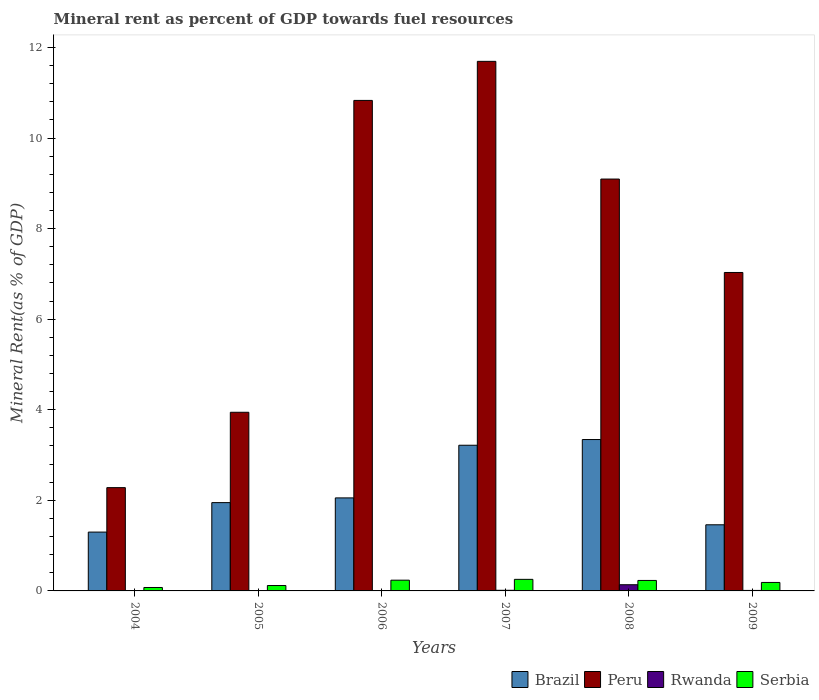Are the number of bars per tick equal to the number of legend labels?
Your answer should be very brief. Yes. How many bars are there on the 1st tick from the left?
Provide a succinct answer. 4. In how many cases, is the number of bars for a given year not equal to the number of legend labels?
Provide a short and direct response. 0. What is the mineral rent in Serbia in 2009?
Provide a short and direct response. 0.19. Across all years, what is the maximum mineral rent in Brazil?
Provide a short and direct response. 3.34. Across all years, what is the minimum mineral rent in Brazil?
Offer a terse response. 1.3. What is the total mineral rent in Peru in the graph?
Offer a very short reply. 44.87. What is the difference between the mineral rent in Serbia in 2005 and that in 2006?
Keep it short and to the point. -0.12. What is the difference between the mineral rent in Peru in 2008 and the mineral rent in Brazil in 2009?
Provide a succinct answer. 7.63. What is the average mineral rent in Rwanda per year?
Your answer should be compact. 0.03. In the year 2009, what is the difference between the mineral rent in Brazil and mineral rent in Peru?
Offer a terse response. -5.57. In how many years, is the mineral rent in Peru greater than 4 %?
Provide a short and direct response. 4. What is the ratio of the mineral rent in Brazil in 2006 to that in 2007?
Make the answer very short. 0.64. Is the mineral rent in Serbia in 2006 less than that in 2009?
Your answer should be compact. No. Is the difference between the mineral rent in Brazil in 2005 and 2007 greater than the difference between the mineral rent in Peru in 2005 and 2007?
Keep it short and to the point. Yes. What is the difference between the highest and the second highest mineral rent in Peru?
Provide a short and direct response. 0.86. What is the difference between the highest and the lowest mineral rent in Peru?
Offer a very short reply. 9.41. Is the sum of the mineral rent in Rwanda in 2005 and 2006 greater than the maximum mineral rent in Peru across all years?
Provide a succinct answer. No. Is it the case that in every year, the sum of the mineral rent in Rwanda and mineral rent in Brazil is greater than the sum of mineral rent in Peru and mineral rent in Serbia?
Your response must be concise. No. What does the 1st bar from the left in 2007 represents?
Make the answer very short. Brazil. What does the 4th bar from the right in 2008 represents?
Provide a short and direct response. Brazil. What is the difference between two consecutive major ticks on the Y-axis?
Keep it short and to the point. 2. Are the values on the major ticks of Y-axis written in scientific E-notation?
Provide a succinct answer. No. What is the title of the graph?
Offer a terse response. Mineral rent as percent of GDP towards fuel resources. Does "France" appear as one of the legend labels in the graph?
Offer a very short reply. No. What is the label or title of the Y-axis?
Ensure brevity in your answer.  Mineral Rent(as % of GDP). What is the Mineral Rent(as % of GDP) of Brazil in 2004?
Provide a short and direct response. 1.3. What is the Mineral Rent(as % of GDP) in Peru in 2004?
Keep it short and to the point. 2.28. What is the Mineral Rent(as % of GDP) in Rwanda in 2004?
Keep it short and to the point. 0. What is the Mineral Rent(as % of GDP) in Serbia in 2004?
Keep it short and to the point. 0.08. What is the Mineral Rent(as % of GDP) of Brazil in 2005?
Keep it short and to the point. 1.95. What is the Mineral Rent(as % of GDP) of Peru in 2005?
Make the answer very short. 3.94. What is the Mineral Rent(as % of GDP) in Rwanda in 2005?
Ensure brevity in your answer.  0. What is the Mineral Rent(as % of GDP) of Serbia in 2005?
Your answer should be compact. 0.12. What is the Mineral Rent(as % of GDP) of Brazil in 2006?
Keep it short and to the point. 2.05. What is the Mineral Rent(as % of GDP) of Peru in 2006?
Your answer should be compact. 10.83. What is the Mineral Rent(as % of GDP) of Rwanda in 2006?
Make the answer very short. 0. What is the Mineral Rent(as % of GDP) of Serbia in 2006?
Your answer should be compact. 0.24. What is the Mineral Rent(as % of GDP) of Brazil in 2007?
Provide a succinct answer. 3.22. What is the Mineral Rent(as % of GDP) in Peru in 2007?
Ensure brevity in your answer.  11.69. What is the Mineral Rent(as % of GDP) of Rwanda in 2007?
Keep it short and to the point. 0.01. What is the Mineral Rent(as % of GDP) in Serbia in 2007?
Make the answer very short. 0.26. What is the Mineral Rent(as % of GDP) in Brazil in 2008?
Provide a succinct answer. 3.34. What is the Mineral Rent(as % of GDP) in Peru in 2008?
Your answer should be very brief. 9.09. What is the Mineral Rent(as % of GDP) of Rwanda in 2008?
Provide a short and direct response. 0.14. What is the Mineral Rent(as % of GDP) of Serbia in 2008?
Provide a succinct answer. 0.23. What is the Mineral Rent(as % of GDP) of Brazil in 2009?
Your answer should be compact. 1.46. What is the Mineral Rent(as % of GDP) in Peru in 2009?
Keep it short and to the point. 7.03. What is the Mineral Rent(as % of GDP) in Rwanda in 2009?
Offer a terse response. 0.01. What is the Mineral Rent(as % of GDP) of Serbia in 2009?
Your answer should be compact. 0.19. Across all years, what is the maximum Mineral Rent(as % of GDP) in Brazil?
Keep it short and to the point. 3.34. Across all years, what is the maximum Mineral Rent(as % of GDP) of Peru?
Your answer should be compact. 11.69. Across all years, what is the maximum Mineral Rent(as % of GDP) of Rwanda?
Your answer should be compact. 0.14. Across all years, what is the maximum Mineral Rent(as % of GDP) in Serbia?
Make the answer very short. 0.26. Across all years, what is the minimum Mineral Rent(as % of GDP) of Brazil?
Your answer should be compact. 1.3. Across all years, what is the minimum Mineral Rent(as % of GDP) of Peru?
Offer a terse response. 2.28. Across all years, what is the minimum Mineral Rent(as % of GDP) in Rwanda?
Your answer should be compact. 0. Across all years, what is the minimum Mineral Rent(as % of GDP) of Serbia?
Make the answer very short. 0.08. What is the total Mineral Rent(as % of GDP) of Brazil in the graph?
Give a very brief answer. 13.32. What is the total Mineral Rent(as % of GDP) of Peru in the graph?
Your answer should be very brief. 44.87. What is the total Mineral Rent(as % of GDP) in Rwanda in the graph?
Ensure brevity in your answer.  0.17. What is the total Mineral Rent(as % of GDP) of Serbia in the graph?
Your answer should be compact. 1.11. What is the difference between the Mineral Rent(as % of GDP) in Brazil in 2004 and that in 2005?
Provide a succinct answer. -0.65. What is the difference between the Mineral Rent(as % of GDP) in Peru in 2004 and that in 2005?
Your answer should be very brief. -1.66. What is the difference between the Mineral Rent(as % of GDP) of Rwanda in 2004 and that in 2005?
Ensure brevity in your answer.  -0. What is the difference between the Mineral Rent(as % of GDP) of Serbia in 2004 and that in 2005?
Your answer should be very brief. -0.04. What is the difference between the Mineral Rent(as % of GDP) of Brazil in 2004 and that in 2006?
Keep it short and to the point. -0.75. What is the difference between the Mineral Rent(as % of GDP) of Peru in 2004 and that in 2006?
Your answer should be very brief. -8.55. What is the difference between the Mineral Rent(as % of GDP) in Rwanda in 2004 and that in 2006?
Make the answer very short. -0. What is the difference between the Mineral Rent(as % of GDP) of Serbia in 2004 and that in 2006?
Your answer should be compact. -0.16. What is the difference between the Mineral Rent(as % of GDP) of Brazil in 2004 and that in 2007?
Offer a very short reply. -1.92. What is the difference between the Mineral Rent(as % of GDP) of Peru in 2004 and that in 2007?
Your response must be concise. -9.41. What is the difference between the Mineral Rent(as % of GDP) of Rwanda in 2004 and that in 2007?
Provide a succinct answer. -0.01. What is the difference between the Mineral Rent(as % of GDP) in Serbia in 2004 and that in 2007?
Provide a short and direct response. -0.18. What is the difference between the Mineral Rent(as % of GDP) in Brazil in 2004 and that in 2008?
Your response must be concise. -2.04. What is the difference between the Mineral Rent(as % of GDP) of Peru in 2004 and that in 2008?
Keep it short and to the point. -6.81. What is the difference between the Mineral Rent(as % of GDP) of Rwanda in 2004 and that in 2008?
Keep it short and to the point. -0.14. What is the difference between the Mineral Rent(as % of GDP) of Serbia in 2004 and that in 2008?
Ensure brevity in your answer.  -0.16. What is the difference between the Mineral Rent(as % of GDP) of Brazil in 2004 and that in 2009?
Provide a succinct answer. -0.16. What is the difference between the Mineral Rent(as % of GDP) in Peru in 2004 and that in 2009?
Your answer should be compact. -4.75. What is the difference between the Mineral Rent(as % of GDP) in Rwanda in 2004 and that in 2009?
Give a very brief answer. -0.01. What is the difference between the Mineral Rent(as % of GDP) of Serbia in 2004 and that in 2009?
Provide a short and direct response. -0.11. What is the difference between the Mineral Rent(as % of GDP) in Brazil in 2005 and that in 2006?
Your response must be concise. -0.1. What is the difference between the Mineral Rent(as % of GDP) of Peru in 2005 and that in 2006?
Your answer should be very brief. -6.89. What is the difference between the Mineral Rent(as % of GDP) in Rwanda in 2005 and that in 2006?
Ensure brevity in your answer.  -0. What is the difference between the Mineral Rent(as % of GDP) in Serbia in 2005 and that in 2006?
Offer a very short reply. -0.12. What is the difference between the Mineral Rent(as % of GDP) in Brazil in 2005 and that in 2007?
Keep it short and to the point. -1.27. What is the difference between the Mineral Rent(as % of GDP) of Peru in 2005 and that in 2007?
Your response must be concise. -7.75. What is the difference between the Mineral Rent(as % of GDP) in Rwanda in 2005 and that in 2007?
Your response must be concise. -0.01. What is the difference between the Mineral Rent(as % of GDP) in Serbia in 2005 and that in 2007?
Make the answer very short. -0.14. What is the difference between the Mineral Rent(as % of GDP) in Brazil in 2005 and that in 2008?
Keep it short and to the point. -1.39. What is the difference between the Mineral Rent(as % of GDP) in Peru in 2005 and that in 2008?
Ensure brevity in your answer.  -5.15. What is the difference between the Mineral Rent(as % of GDP) of Rwanda in 2005 and that in 2008?
Your response must be concise. -0.14. What is the difference between the Mineral Rent(as % of GDP) of Serbia in 2005 and that in 2008?
Your answer should be very brief. -0.11. What is the difference between the Mineral Rent(as % of GDP) of Brazil in 2005 and that in 2009?
Your response must be concise. 0.49. What is the difference between the Mineral Rent(as % of GDP) in Peru in 2005 and that in 2009?
Provide a short and direct response. -3.09. What is the difference between the Mineral Rent(as % of GDP) in Rwanda in 2005 and that in 2009?
Ensure brevity in your answer.  -0.01. What is the difference between the Mineral Rent(as % of GDP) of Serbia in 2005 and that in 2009?
Offer a very short reply. -0.07. What is the difference between the Mineral Rent(as % of GDP) in Brazil in 2006 and that in 2007?
Offer a very short reply. -1.16. What is the difference between the Mineral Rent(as % of GDP) of Peru in 2006 and that in 2007?
Offer a very short reply. -0.86. What is the difference between the Mineral Rent(as % of GDP) in Rwanda in 2006 and that in 2007?
Keep it short and to the point. -0.01. What is the difference between the Mineral Rent(as % of GDP) of Serbia in 2006 and that in 2007?
Your answer should be compact. -0.02. What is the difference between the Mineral Rent(as % of GDP) in Brazil in 2006 and that in 2008?
Provide a short and direct response. -1.29. What is the difference between the Mineral Rent(as % of GDP) in Peru in 2006 and that in 2008?
Your answer should be compact. 1.74. What is the difference between the Mineral Rent(as % of GDP) in Rwanda in 2006 and that in 2008?
Make the answer very short. -0.13. What is the difference between the Mineral Rent(as % of GDP) of Serbia in 2006 and that in 2008?
Make the answer very short. 0.01. What is the difference between the Mineral Rent(as % of GDP) in Brazil in 2006 and that in 2009?
Your response must be concise. 0.59. What is the difference between the Mineral Rent(as % of GDP) of Peru in 2006 and that in 2009?
Your answer should be very brief. 3.8. What is the difference between the Mineral Rent(as % of GDP) of Rwanda in 2006 and that in 2009?
Provide a succinct answer. -0.01. What is the difference between the Mineral Rent(as % of GDP) of Serbia in 2006 and that in 2009?
Offer a terse response. 0.05. What is the difference between the Mineral Rent(as % of GDP) of Brazil in 2007 and that in 2008?
Offer a very short reply. -0.13. What is the difference between the Mineral Rent(as % of GDP) of Peru in 2007 and that in 2008?
Offer a terse response. 2.6. What is the difference between the Mineral Rent(as % of GDP) in Rwanda in 2007 and that in 2008?
Offer a terse response. -0.12. What is the difference between the Mineral Rent(as % of GDP) of Serbia in 2007 and that in 2008?
Provide a short and direct response. 0.02. What is the difference between the Mineral Rent(as % of GDP) of Brazil in 2007 and that in 2009?
Give a very brief answer. 1.76. What is the difference between the Mineral Rent(as % of GDP) in Peru in 2007 and that in 2009?
Ensure brevity in your answer.  4.66. What is the difference between the Mineral Rent(as % of GDP) of Rwanda in 2007 and that in 2009?
Your answer should be compact. 0. What is the difference between the Mineral Rent(as % of GDP) of Serbia in 2007 and that in 2009?
Ensure brevity in your answer.  0.07. What is the difference between the Mineral Rent(as % of GDP) in Brazil in 2008 and that in 2009?
Your answer should be compact. 1.88. What is the difference between the Mineral Rent(as % of GDP) in Peru in 2008 and that in 2009?
Ensure brevity in your answer.  2.06. What is the difference between the Mineral Rent(as % of GDP) in Rwanda in 2008 and that in 2009?
Your answer should be very brief. 0.13. What is the difference between the Mineral Rent(as % of GDP) in Serbia in 2008 and that in 2009?
Make the answer very short. 0.04. What is the difference between the Mineral Rent(as % of GDP) of Brazil in 2004 and the Mineral Rent(as % of GDP) of Peru in 2005?
Provide a short and direct response. -2.65. What is the difference between the Mineral Rent(as % of GDP) of Brazil in 2004 and the Mineral Rent(as % of GDP) of Rwanda in 2005?
Your answer should be compact. 1.3. What is the difference between the Mineral Rent(as % of GDP) in Brazil in 2004 and the Mineral Rent(as % of GDP) in Serbia in 2005?
Your response must be concise. 1.18. What is the difference between the Mineral Rent(as % of GDP) of Peru in 2004 and the Mineral Rent(as % of GDP) of Rwanda in 2005?
Your response must be concise. 2.28. What is the difference between the Mineral Rent(as % of GDP) of Peru in 2004 and the Mineral Rent(as % of GDP) of Serbia in 2005?
Ensure brevity in your answer.  2.16. What is the difference between the Mineral Rent(as % of GDP) of Rwanda in 2004 and the Mineral Rent(as % of GDP) of Serbia in 2005?
Offer a terse response. -0.12. What is the difference between the Mineral Rent(as % of GDP) of Brazil in 2004 and the Mineral Rent(as % of GDP) of Peru in 2006?
Ensure brevity in your answer.  -9.53. What is the difference between the Mineral Rent(as % of GDP) in Brazil in 2004 and the Mineral Rent(as % of GDP) in Rwanda in 2006?
Provide a succinct answer. 1.29. What is the difference between the Mineral Rent(as % of GDP) of Brazil in 2004 and the Mineral Rent(as % of GDP) of Serbia in 2006?
Your answer should be compact. 1.06. What is the difference between the Mineral Rent(as % of GDP) in Peru in 2004 and the Mineral Rent(as % of GDP) in Rwanda in 2006?
Provide a short and direct response. 2.28. What is the difference between the Mineral Rent(as % of GDP) in Peru in 2004 and the Mineral Rent(as % of GDP) in Serbia in 2006?
Your answer should be compact. 2.04. What is the difference between the Mineral Rent(as % of GDP) of Rwanda in 2004 and the Mineral Rent(as % of GDP) of Serbia in 2006?
Offer a very short reply. -0.24. What is the difference between the Mineral Rent(as % of GDP) in Brazil in 2004 and the Mineral Rent(as % of GDP) in Peru in 2007?
Provide a succinct answer. -10.39. What is the difference between the Mineral Rent(as % of GDP) of Brazil in 2004 and the Mineral Rent(as % of GDP) of Rwanda in 2007?
Offer a very short reply. 1.29. What is the difference between the Mineral Rent(as % of GDP) of Brazil in 2004 and the Mineral Rent(as % of GDP) of Serbia in 2007?
Offer a terse response. 1.04. What is the difference between the Mineral Rent(as % of GDP) of Peru in 2004 and the Mineral Rent(as % of GDP) of Rwanda in 2007?
Your answer should be compact. 2.27. What is the difference between the Mineral Rent(as % of GDP) in Peru in 2004 and the Mineral Rent(as % of GDP) in Serbia in 2007?
Make the answer very short. 2.02. What is the difference between the Mineral Rent(as % of GDP) of Rwanda in 2004 and the Mineral Rent(as % of GDP) of Serbia in 2007?
Keep it short and to the point. -0.25. What is the difference between the Mineral Rent(as % of GDP) in Brazil in 2004 and the Mineral Rent(as % of GDP) in Peru in 2008?
Your answer should be compact. -7.79. What is the difference between the Mineral Rent(as % of GDP) of Brazil in 2004 and the Mineral Rent(as % of GDP) of Rwanda in 2008?
Make the answer very short. 1.16. What is the difference between the Mineral Rent(as % of GDP) of Brazil in 2004 and the Mineral Rent(as % of GDP) of Serbia in 2008?
Provide a succinct answer. 1.07. What is the difference between the Mineral Rent(as % of GDP) of Peru in 2004 and the Mineral Rent(as % of GDP) of Rwanda in 2008?
Your answer should be very brief. 2.14. What is the difference between the Mineral Rent(as % of GDP) of Peru in 2004 and the Mineral Rent(as % of GDP) of Serbia in 2008?
Offer a very short reply. 2.05. What is the difference between the Mineral Rent(as % of GDP) of Rwanda in 2004 and the Mineral Rent(as % of GDP) of Serbia in 2008?
Give a very brief answer. -0.23. What is the difference between the Mineral Rent(as % of GDP) of Brazil in 2004 and the Mineral Rent(as % of GDP) of Peru in 2009?
Offer a very short reply. -5.73. What is the difference between the Mineral Rent(as % of GDP) of Brazil in 2004 and the Mineral Rent(as % of GDP) of Rwanda in 2009?
Make the answer very short. 1.29. What is the difference between the Mineral Rent(as % of GDP) of Brazil in 2004 and the Mineral Rent(as % of GDP) of Serbia in 2009?
Provide a short and direct response. 1.11. What is the difference between the Mineral Rent(as % of GDP) in Peru in 2004 and the Mineral Rent(as % of GDP) in Rwanda in 2009?
Provide a short and direct response. 2.27. What is the difference between the Mineral Rent(as % of GDP) of Peru in 2004 and the Mineral Rent(as % of GDP) of Serbia in 2009?
Provide a short and direct response. 2.09. What is the difference between the Mineral Rent(as % of GDP) in Rwanda in 2004 and the Mineral Rent(as % of GDP) in Serbia in 2009?
Offer a very short reply. -0.19. What is the difference between the Mineral Rent(as % of GDP) of Brazil in 2005 and the Mineral Rent(as % of GDP) of Peru in 2006?
Keep it short and to the point. -8.88. What is the difference between the Mineral Rent(as % of GDP) in Brazil in 2005 and the Mineral Rent(as % of GDP) in Rwanda in 2006?
Offer a very short reply. 1.95. What is the difference between the Mineral Rent(as % of GDP) of Brazil in 2005 and the Mineral Rent(as % of GDP) of Serbia in 2006?
Your answer should be very brief. 1.71. What is the difference between the Mineral Rent(as % of GDP) of Peru in 2005 and the Mineral Rent(as % of GDP) of Rwanda in 2006?
Your answer should be very brief. 3.94. What is the difference between the Mineral Rent(as % of GDP) of Peru in 2005 and the Mineral Rent(as % of GDP) of Serbia in 2006?
Provide a short and direct response. 3.71. What is the difference between the Mineral Rent(as % of GDP) in Rwanda in 2005 and the Mineral Rent(as % of GDP) in Serbia in 2006?
Provide a succinct answer. -0.24. What is the difference between the Mineral Rent(as % of GDP) of Brazil in 2005 and the Mineral Rent(as % of GDP) of Peru in 2007?
Your response must be concise. -9.74. What is the difference between the Mineral Rent(as % of GDP) of Brazil in 2005 and the Mineral Rent(as % of GDP) of Rwanda in 2007?
Ensure brevity in your answer.  1.94. What is the difference between the Mineral Rent(as % of GDP) of Brazil in 2005 and the Mineral Rent(as % of GDP) of Serbia in 2007?
Ensure brevity in your answer.  1.69. What is the difference between the Mineral Rent(as % of GDP) of Peru in 2005 and the Mineral Rent(as % of GDP) of Rwanda in 2007?
Your answer should be very brief. 3.93. What is the difference between the Mineral Rent(as % of GDP) in Peru in 2005 and the Mineral Rent(as % of GDP) in Serbia in 2007?
Keep it short and to the point. 3.69. What is the difference between the Mineral Rent(as % of GDP) in Rwanda in 2005 and the Mineral Rent(as % of GDP) in Serbia in 2007?
Offer a terse response. -0.25. What is the difference between the Mineral Rent(as % of GDP) of Brazil in 2005 and the Mineral Rent(as % of GDP) of Peru in 2008?
Your response must be concise. -7.14. What is the difference between the Mineral Rent(as % of GDP) in Brazil in 2005 and the Mineral Rent(as % of GDP) in Rwanda in 2008?
Keep it short and to the point. 1.81. What is the difference between the Mineral Rent(as % of GDP) in Brazil in 2005 and the Mineral Rent(as % of GDP) in Serbia in 2008?
Provide a succinct answer. 1.72. What is the difference between the Mineral Rent(as % of GDP) in Peru in 2005 and the Mineral Rent(as % of GDP) in Rwanda in 2008?
Keep it short and to the point. 3.81. What is the difference between the Mineral Rent(as % of GDP) in Peru in 2005 and the Mineral Rent(as % of GDP) in Serbia in 2008?
Provide a short and direct response. 3.71. What is the difference between the Mineral Rent(as % of GDP) in Rwanda in 2005 and the Mineral Rent(as % of GDP) in Serbia in 2008?
Give a very brief answer. -0.23. What is the difference between the Mineral Rent(as % of GDP) in Brazil in 2005 and the Mineral Rent(as % of GDP) in Peru in 2009?
Provide a succinct answer. -5.08. What is the difference between the Mineral Rent(as % of GDP) of Brazil in 2005 and the Mineral Rent(as % of GDP) of Rwanda in 2009?
Offer a very short reply. 1.94. What is the difference between the Mineral Rent(as % of GDP) in Brazil in 2005 and the Mineral Rent(as % of GDP) in Serbia in 2009?
Provide a succinct answer. 1.76. What is the difference between the Mineral Rent(as % of GDP) in Peru in 2005 and the Mineral Rent(as % of GDP) in Rwanda in 2009?
Offer a terse response. 3.93. What is the difference between the Mineral Rent(as % of GDP) in Peru in 2005 and the Mineral Rent(as % of GDP) in Serbia in 2009?
Offer a terse response. 3.76. What is the difference between the Mineral Rent(as % of GDP) in Rwanda in 2005 and the Mineral Rent(as % of GDP) in Serbia in 2009?
Make the answer very short. -0.19. What is the difference between the Mineral Rent(as % of GDP) in Brazil in 2006 and the Mineral Rent(as % of GDP) in Peru in 2007?
Give a very brief answer. -9.64. What is the difference between the Mineral Rent(as % of GDP) of Brazil in 2006 and the Mineral Rent(as % of GDP) of Rwanda in 2007?
Keep it short and to the point. 2.04. What is the difference between the Mineral Rent(as % of GDP) in Brazil in 2006 and the Mineral Rent(as % of GDP) in Serbia in 2007?
Ensure brevity in your answer.  1.8. What is the difference between the Mineral Rent(as % of GDP) of Peru in 2006 and the Mineral Rent(as % of GDP) of Rwanda in 2007?
Offer a terse response. 10.82. What is the difference between the Mineral Rent(as % of GDP) of Peru in 2006 and the Mineral Rent(as % of GDP) of Serbia in 2007?
Offer a terse response. 10.57. What is the difference between the Mineral Rent(as % of GDP) in Rwanda in 2006 and the Mineral Rent(as % of GDP) in Serbia in 2007?
Offer a terse response. -0.25. What is the difference between the Mineral Rent(as % of GDP) of Brazil in 2006 and the Mineral Rent(as % of GDP) of Peru in 2008?
Make the answer very short. -7.04. What is the difference between the Mineral Rent(as % of GDP) of Brazil in 2006 and the Mineral Rent(as % of GDP) of Rwanda in 2008?
Your answer should be compact. 1.92. What is the difference between the Mineral Rent(as % of GDP) of Brazil in 2006 and the Mineral Rent(as % of GDP) of Serbia in 2008?
Provide a short and direct response. 1.82. What is the difference between the Mineral Rent(as % of GDP) of Peru in 2006 and the Mineral Rent(as % of GDP) of Rwanda in 2008?
Ensure brevity in your answer.  10.69. What is the difference between the Mineral Rent(as % of GDP) in Peru in 2006 and the Mineral Rent(as % of GDP) in Serbia in 2008?
Give a very brief answer. 10.6. What is the difference between the Mineral Rent(as % of GDP) of Rwanda in 2006 and the Mineral Rent(as % of GDP) of Serbia in 2008?
Your answer should be very brief. -0.23. What is the difference between the Mineral Rent(as % of GDP) of Brazil in 2006 and the Mineral Rent(as % of GDP) of Peru in 2009?
Your answer should be very brief. -4.98. What is the difference between the Mineral Rent(as % of GDP) of Brazil in 2006 and the Mineral Rent(as % of GDP) of Rwanda in 2009?
Ensure brevity in your answer.  2.04. What is the difference between the Mineral Rent(as % of GDP) of Brazil in 2006 and the Mineral Rent(as % of GDP) of Serbia in 2009?
Provide a succinct answer. 1.87. What is the difference between the Mineral Rent(as % of GDP) in Peru in 2006 and the Mineral Rent(as % of GDP) in Rwanda in 2009?
Provide a short and direct response. 10.82. What is the difference between the Mineral Rent(as % of GDP) of Peru in 2006 and the Mineral Rent(as % of GDP) of Serbia in 2009?
Provide a succinct answer. 10.64. What is the difference between the Mineral Rent(as % of GDP) in Rwanda in 2006 and the Mineral Rent(as % of GDP) in Serbia in 2009?
Ensure brevity in your answer.  -0.18. What is the difference between the Mineral Rent(as % of GDP) in Brazil in 2007 and the Mineral Rent(as % of GDP) in Peru in 2008?
Give a very brief answer. -5.88. What is the difference between the Mineral Rent(as % of GDP) of Brazil in 2007 and the Mineral Rent(as % of GDP) of Rwanda in 2008?
Offer a very short reply. 3.08. What is the difference between the Mineral Rent(as % of GDP) of Brazil in 2007 and the Mineral Rent(as % of GDP) of Serbia in 2008?
Offer a very short reply. 2.98. What is the difference between the Mineral Rent(as % of GDP) in Peru in 2007 and the Mineral Rent(as % of GDP) in Rwanda in 2008?
Your answer should be very brief. 11.56. What is the difference between the Mineral Rent(as % of GDP) of Peru in 2007 and the Mineral Rent(as % of GDP) of Serbia in 2008?
Provide a short and direct response. 11.46. What is the difference between the Mineral Rent(as % of GDP) in Rwanda in 2007 and the Mineral Rent(as % of GDP) in Serbia in 2008?
Offer a terse response. -0.22. What is the difference between the Mineral Rent(as % of GDP) of Brazil in 2007 and the Mineral Rent(as % of GDP) of Peru in 2009?
Make the answer very short. -3.81. What is the difference between the Mineral Rent(as % of GDP) of Brazil in 2007 and the Mineral Rent(as % of GDP) of Rwanda in 2009?
Your answer should be very brief. 3.21. What is the difference between the Mineral Rent(as % of GDP) in Brazil in 2007 and the Mineral Rent(as % of GDP) in Serbia in 2009?
Your answer should be very brief. 3.03. What is the difference between the Mineral Rent(as % of GDP) of Peru in 2007 and the Mineral Rent(as % of GDP) of Rwanda in 2009?
Ensure brevity in your answer.  11.68. What is the difference between the Mineral Rent(as % of GDP) of Peru in 2007 and the Mineral Rent(as % of GDP) of Serbia in 2009?
Offer a terse response. 11.51. What is the difference between the Mineral Rent(as % of GDP) in Rwanda in 2007 and the Mineral Rent(as % of GDP) in Serbia in 2009?
Provide a short and direct response. -0.17. What is the difference between the Mineral Rent(as % of GDP) of Brazil in 2008 and the Mineral Rent(as % of GDP) of Peru in 2009?
Ensure brevity in your answer.  -3.69. What is the difference between the Mineral Rent(as % of GDP) of Brazil in 2008 and the Mineral Rent(as % of GDP) of Rwanda in 2009?
Offer a terse response. 3.33. What is the difference between the Mineral Rent(as % of GDP) in Brazil in 2008 and the Mineral Rent(as % of GDP) in Serbia in 2009?
Your answer should be very brief. 3.16. What is the difference between the Mineral Rent(as % of GDP) of Peru in 2008 and the Mineral Rent(as % of GDP) of Rwanda in 2009?
Your answer should be very brief. 9.08. What is the difference between the Mineral Rent(as % of GDP) in Peru in 2008 and the Mineral Rent(as % of GDP) in Serbia in 2009?
Your response must be concise. 8.91. What is the difference between the Mineral Rent(as % of GDP) of Rwanda in 2008 and the Mineral Rent(as % of GDP) of Serbia in 2009?
Your answer should be compact. -0.05. What is the average Mineral Rent(as % of GDP) of Brazil per year?
Offer a very short reply. 2.22. What is the average Mineral Rent(as % of GDP) of Peru per year?
Your answer should be compact. 7.48. What is the average Mineral Rent(as % of GDP) in Rwanda per year?
Keep it short and to the point. 0.03. What is the average Mineral Rent(as % of GDP) in Serbia per year?
Provide a short and direct response. 0.18. In the year 2004, what is the difference between the Mineral Rent(as % of GDP) of Brazil and Mineral Rent(as % of GDP) of Peru?
Offer a terse response. -0.98. In the year 2004, what is the difference between the Mineral Rent(as % of GDP) of Brazil and Mineral Rent(as % of GDP) of Rwanda?
Offer a terse response. 1.3. In the year 2004, what is the difference between the Mineral Rent(as % of GDP) in Brazil and Mineral Rent(as % of GDP) in Serbia?
Your answer should be compact. 1.22. In the year 2004, what is the difference between the Mineral Rent(as % of GDP) in Peru and Mineral Rent(as % of GDP) in Rwanda?
Give a very brief answer. 2.28. In the year 2004, what is the difference between the Mineral Rent(as % of GDP) in Peru and Mineral Rent(as % of GDP) in Serbia?
Your answer should be very brief. 2.2. In the year 2004, what is the difference between the Mineral Rent(as % of GDP) in Rwanda and Mineral Rent(as % of GDP) in Serbia?
Offer a very short reply. -0.07. In the year 2005, what is the difference between the Mineral Rent(as % of GDP) in Brazil and Mineral Rent(as % of GDP) in Peru?
Provide a short and direct response. -1.99. In the year 2005, what is the difference between the Mineral Rent(as % of GDP) in Brazil and Mineral Rent(as % of GDP) in Rwanda?
Ensure brevity in your answer.  1.95. In the year 2005, what is the difference between the Mineral Rent(as % of GDP) in Brazil and Mineral Rent(as % of GDP) in Serbia?
Give a very brief answer. 1.83. In the year 2005, what is the difference between the Mineral Rent(as % of GDP) in Peru and Mineral Rent(as % of GDP) in Rwanda?
Provide a short and direct response. 3.94. In the year 2005, what is the difference between the Mineral Rent(as % of GDP) in Peru and Mineral Rent(as % of GDP) in Serbia?
Offer a terse response. 3.83. In the year 2005, what is the difference between the Mineral Rent(as % of GDP) of Rwanda and Mineral Rent(as % of GDP) of Serbia?
Give a very brief answer. -0.12. In the year 2006, what is the difference between the Mineral Rent(as % of GDP) of Brazil and Mineral Rent(as % of GDP) of Peru?
Give a very brief answer. -8.78. In the year 2006, what is the difference between the Mineral Rent(as % of GDP) in Brazil and Mineral Rent(as % of GDP) in Rwanda?
Offer a very short reply. 2.05. In the year 2006, what is the difference between the Mineral Rent(as % of GDP) of Brazil and Mineral Rent(as % of GDP) of Serbia?
Make the answer very short. 1.82. In the year 2006, what is the difference between the Mineral Rent(as % of GDP) of Peru and Mineral Rent(as % of GDP) of Rwanda?
Your response must be concise. 10.83. In the year 2006, what is the difference between the Mineral Rent(as % of GDP) in Peru and Mineral Rent(as % of GDP) in Serbia?
Provide a succinct answer. 10.59. In the year 2006, what is the difference between the Mineral Rent(as % of GDP) in Rwanda and Mineral Rent(as % of GDP) in Serbia?
Your answer should be compact. -0.23. In the year 2007, what is the difference between the Mineral Rent(as % of GDP) in Brazil and Mineral Rent(as % of GDP) in Peru?
Your answer should be compact. -8.48. In the year 2007, what is the difference between the Mineral Rent(as % of GDP) in Brazil and Mineral Rent(as % of GDP) in Rwanda?
Offer a very short reply. 3.2. In the year 2007, what is the difference between the Mineral Rent(as % of GDP) in Brazil and Mineral Rent(as % of GDP) in Serbia?
Offer a terse response. 2.96. In the year 2007, what is the difference between the Mineral Rent(as % of GDP) of Peru and Mineral Rent(as % of GDP) of Rwanda?
Provide a succinct answer. 11.68. In the year 2007, what is the difference between the Mineral Rent(as % of GDP) in Peru and Mineral Rent(as % of GDP) in Serbia?
Make the answer very short. 11.44. In the year 2007, what is the difference between the Mineral Rent(as % of GDP) of Rwanda and Mineral Rent(as % of GDP) of Serbia?
Provide a succinct answer. -0.24. In the year 2008, what is the difference between the Mineral Rent(as % of GDP) in Brazil and Mineral Rent(as % of GDP) in Peru?
Make the answer very short. -5.75. In the year 2008, what is the difference between the Mineral Rent(as % of GDP) of Brazil and Mineral Rent(as % of GDP) of Rwanda?
Provide a succinct answer. 3.21. In the year 2008, what is the difference between the Mineral Rent(as % of GDP) in Brazil and Mineral Rent(as % of GDP) in Serbia?
Provide a succinct answer. 3.11. In the year 2008, what is the difference between the Mineral Rent(as % of GDP) in Peru and Mineral Rent(as % of GDP) in Rwanda?
Your answer should be compact. 8.96. In the year 2008, what is the difference between the Mineral Rent(as % of GDP) in Peru and Mineral Rent(as % of GDP) in Serbia?
Offer a very short reply. 8.86. In the year 2008, what is the difference between the Mineral Rent(as % of GDP) of Rwanda and Mineral Rent(as % of GDP) of Serbia?
Provide a succinct answer. -0.09. In the year 2009, what is the difference between the Mineral Rent(as % of GDP) of Brazil and Mineral Rent(as % of GDP) of Peru?
Offer a very short reply. -5.57. In the year 2009, what is the difference between the Mineral Rent(as % of GDP) in Brazil and Mineral Rent(as % of GDP) in Rwanda?
Your answer should be compact. 1.45. In the year 2009, what is the difference between the Mineral Rent(as % of GDP) in Brazil and Mineral Rent(as % of GDP) in Serbia?
Make the answer very short. 1.27. In the year 2009, what is the difference between the Mineral Rent(as % of GDP) of Peru and Mineral Rent(as % of GDP) of Rwanda?
Keep it short and to the point. 7.02. In the year 2009, what is the difference between the Mineral Rent(as % of GDP) in Peru and Mineral Rent(as % of GDP) in Serbia?
Offer a very short reply. 6.84. In the year 2009, what is the difference between the Mineral Rent(as % of GDP) in Rwanda and Mineral Rent(as % of GDP) in Serbia?
Give a very brief answer. -0.18. What is the ratio of the Mineral Rent(as % of GDP) of Brazil in 2004 to that in 2005?
Your answer should be compact. 0.67. What is the ratio of the Mineral Rent(as % of GDP) of Peru in 2004 to that in 2005?
Provide a succinct answer. 0.58. What is the ratio of the Mineral Rent(as % of GDP) in Rwanda in 2004 to that in 2005?
Keep it short and to the point. 0.48. What is the ratio of the Mineral Rent(as % of GDP) in Serbia in 2004 to that in 2005?
Your response must be concise. 0.64. What is the ratio of the Mineral Rent(as % of GDP) of Brazil in 2004 to that in 2006?
Provide a short and direct response. 0.63. What is the ratio of the Mineral Rent(as % of GDP) of Peru in 2004 to that in 2006?
Keep it short and to the point. 0.21. What is the ratio of the Mineral Rent(as % of GDP) of Rwanda in 2004 to that in 2006?
Give a very brief answer. 0.16. What is the ratio of the Mineral Rent(as % of GDP) of Serbia in 2004 to that in 2006?
Offer a terse response. 0.32. What is the ratio of the Mineral Rent(as % of GDP) of Brazil in 2004 to that in 2007?
Ensure brevity in your answer.  0.4. What is the ratio of the Mineral Rent(as % of GDP) in Peru in 2004 to that in 2007?
Provide a succinct answer. 0.2. What is the ratio of the Mineral Rent(as % of GDP) of Rwanda in 2004 to that in 2007?
Provide a succinct answer. 0.05. What is the ratio of the Mineral Rent(as % of GDP) of Serbia in 2004 to that in 2007?
Ensure brevity in your answer.  0.3. What is the ratio of the Mineral Rent(as % of GDP) in Brazil in 2004 to that in 2008?
Provide a succinct answer. 0.39. What is the ratio of the Mineral Rent(as % of GDP) in Peru in 2004 to that in 2008?
Give a very brief answer. 0.25. What is the ratio of the Mineral Rent(as % of GDP) in Rwanda in 2004 to that in 2008?
Keep it short and to the point. 0. What is the ratio of the Mineral Rent(as % of GDP) in Serbia in 2004 to that in 2008?
Your answer should be very brief. 0.33. What is the ratio of the Mineral Rent(as % of GDP) of Brazil in 2004 to that in 2009?
Offer a terse response. 0.89. What is the ratio of the Mineral Rent(as % of GDP) of Peru in 2004 to that in 2009?
Your response must be concise. 0.32. What is the ratio of the Mineral Rent(as % of GDP) of Rwanda in 2004 to that in 2009?
Your answer should be compact. 0.06. What is the ratio of the Mineral Rent(as % of GDP) of Serbia in 2004 to that in 2009?
Ensure brevity in your answer.  0.4. What is the ratio of the Mineral Rent(as % of GDP) in Brazil in 2005 to that in 2006?
Offer a very short reply. 0.95. What is the ratio of the Mineral Rent(as % of GDP) of Peru in 2005 to that in 2006?
Ensure brevity in your answer.  0.36. What is the ratio of the Mineral Rent(as % of GDP) of Rwanda in 2005 to that in 2006?
Your response must be concise. 0.34. What is the ratio of the Mineral Rent(as % of GDP) in Serbia in 2005 to that in 2006?
Your answer should be compact. 0.5. What is the ratio of the Mineral Rent(as % of GDP) of Brazil in 2005 to that in 2007?
Provide a succinct answer. 0.61. What is the ratio of the Mineral Rent(as % of GDP) in Peru in 2005 to that in 2007?
Give a very brief answer. 0.34. What is the ratio of the Mineral Rent(as % of GDP) of Rwanda in 2005 to that in 2007?
Your answer should be compact. 0.1. What is the ratio of the Mineral Rent(as % of GDP) in Serbia in 2005 to that in 2007?
Give a very brief answer. 0.47. What is the ratio of the Mineral Rent(as % of GDP) of Brazil in 2005 to that in 2008?
Your answer should be compact. 0.58. What is the ratio of the Mineral Rent(as % of GDP) in Peru in 2005 to that in 2008?
Keep it short and to the point. 0.43. What is the ratio of the Mineral Rent(as % of GDP) of Rwanda in 2005 to that in 2008?
Your answer should be very brief. 0.01. What is the ratio of the Mineral Rent(as % of GDP) of Serbia in 2005 to that in 2008?
Offer a terse response. 0.51. What is the ratio of the Mineral Rent(as % of GDP) of Brazil in 2005 to that in 2009?
Your answer should be very brief. 1.34. What is the ratio of the Mineral Rent(as % of GDP) of Peru in 2005 to that in 2009?
Your answer should be compact. 0.56. What is the ratio of the Mineral Rent(as % of GDP) in Rwanda in 2005 to that in 2009?
Your answer should be compact. 0.13. What is the ratio of the Mineral Rent(as % of GDP) of Serbia in 2005 to that in 2009?
Provide a short and direct response. 0.64. What is the ratio of the Mineral Rent(as % of GDP) of Brazil in 2006 to that in 2007?
Your response must be concise. 0.64. What is the ratio of the Mineral Rent(as % of GDP) of Peru in 2006 to that in 2007?
Provide a short and direct response. 0.93. What is the ratio of the Mineral Rent(as % of GDP) in Rwanda in 2006 to that in 2007?
Provide a short and direct response. 0.29. What is the ratio of the Mineral Rent(as % of GDP) of Serbia in 2006 to that in 2007?
Offer a very short reply. 0.93. What is the ratio of the Mineral Rent(as % of GDP) in Brazil in 2006 to that in 2008?
Your answer should be very brief. 0.61. What is the ratio of the Mineral Rent(as % of GDP) in Peru in 2006 to that in 2008?
Offer a terse response. 1.19. What is the ratio of the Mineral Rent(as % of GDP) in Rwanda in 2006 to that in 2008?
Your answer should be compact. 0.03. What is the ratio of the Mineral Rent(as % of GDP) of Serbia in 2006 to that in 2008?
Make the answer very short. 1.02. What is the ratio of the Mineral Rent(as % of GDP) of Brazil in 2006 to that in 2009?
Your response must be concise. 1.41. What is the ratio of the Mineral Rent(as % of GDP) in Peru in 2006 to that in 2009?
Offer a terse response. 1.54. What is the ratio of the Mineral Rent(as % of GDP) in Rwanda in 2006 to that in 2009?
Give a very brief answer. 0.37. What is the ratio of the Mineral Rent(as % of GDP) of Serbia in 2006 to that in 2009?
Keep it short and to the point. 1.27. What is the ratio of the Mineral Rent(as % of GDP) in Brazil in 2007 to that in 2008?
Your response must be concise. 0.96. What is the ratio of the Mineral Rent(as % of GDP) of Peru in 2007 to that in 2008?
Keep it short and to the point. 1.29. What is the ratio of the Mineral Rent(as % of GDP) in Rwanda in 2007 to that in 2008?
Your response must be concise. 0.1. What is the ratio of the Mineral Rent(as % of GDP) in Serbia in 2007 to that in 2008?
Your response must be concise. 1.1. What is the ratio of the Mineral Rent(as % of GDP) of Brazil in 2007 to that in 2009?
Make the answer very short. 2.2. What is the ratio of the Mineral Rent(as % of GDP) in Peru in 2007 to that in 2009?
Your answer should be compact. 1.66. What is the ratio of the Mineral Rent(as % of GDP) of Rwanda in 2007 to that in 2009?
Your response must be concise. 1.26. What is the ratio of the Mineral Rent(as % of GDP) in Serbia in 2007 to that in 2009?
Offer a very short reply. 1.37. What is the ratio of the Mineral Rent(as % of GDP) in Brazil in 2008 to that in 2009?
Provide a short and direct response. 2.29. What is the ratio of the Mineral Rent(as % of GDP) in Peru in 2008 to that in 2009?
Your answer should be very brief. 1.29. What is the ratio of the Mineral Rent(as % of GDP) of Rwanda in 2008 to that in 2009?
Your response must be concise. 12.42. What is the ratio of the Mineral Rent(as % of GDP) of Serbia in 2008 to that in 2009?
Offer a terse response. 1.24. What is the difference between the highest and the second highest Mineral Rent(as % of GDP) of Brazil?
Provide a succinct answer. 0.13. What is the difference between the highest and the second highest Mineral Rent(as % of GDP) in Peru?
Provide a short and direct response. 0.86. What is the difference between the highest and the second highest Mineral Rent(as % of GDP) in Rwanda?
Keep it short and to the point. 0.12. What is the difference between the highest and the second highest Mineral Rent(as % of GDP) of Serbia?
Offer a very short reply. 0.02. What is the difference between the highest and the lowest Mineral Rent(as % of GDP) in Brazil?
Provide a short and direct response. 2.04. What is the difference between the highest and the lowest Mineral Rent(as % of GDP) in Peru?
Your answer should be compact. 9.41. What is the difference between the highest and the lowest Mineral Rent(as % of GDP) of Rwanda?
Keep it short and to the point. 0.14. What is the difference between the highest and the lowest Mineral Rent(as % of GDP) in Serbia?
Provide a short and direct response. 0.18. 